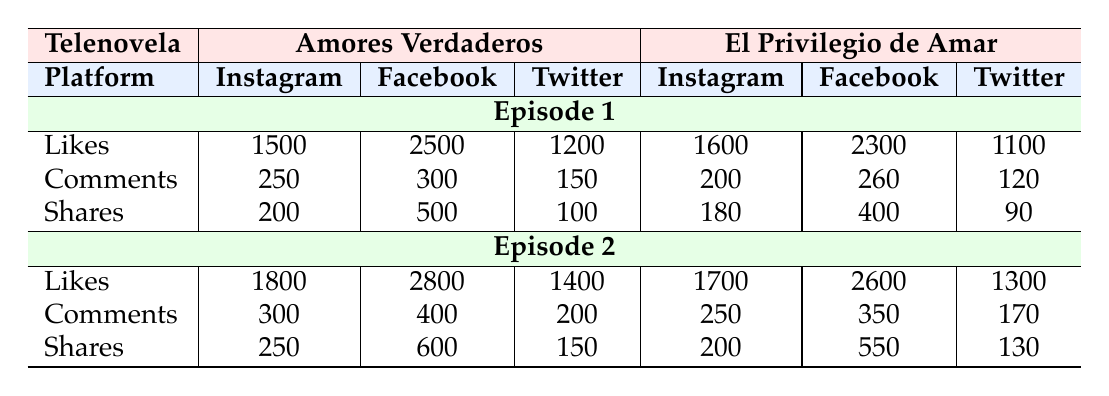What are the total likes for "Amores Verdaderos" Episode 1 across all platforms? To find the total likes for "Amores Verdaderos" Episode 1, we need to sum the likes from Instagram, Facebook, and Twitter: 1500 (Instagram) + 2500 (Facebook) + 1200 (Twitter) = 5200.
Answer: 5200 Which platform had the most shares for "El Privilegio de Amar" Episode 2? For "El Privilegio de Amar" Episode 2, the shares by platform are: Instagram with 200, Facebook with 550, and Twitter with 130. The highest number of shares is from Facebook, which has 550 shares.
Answer: Facebook What is the difference in likes between "Amores Verdaderos" and "El Privilegio de Amar" Episode 1 on Facebook? For Episode 1 on Facebook, "Amores Verdaderos" has 2500 likes, and "El Privilegio de Amar" has 2300 likes. The difference is 2500 - 2300 = 200 likes.
Answer: 200 Did "Amores Verdaderos" Episode 2 have more comments on Instagram than Episode 1? For "Amores Verdaderos" Episode 2 on Instagram, there are 300 comments while Episode 1 has 250 comments. Since 300 is greater than 250, it is true that Episode 2 had more comments.
Answer: Yes What is the average number of shares for "El Privilegio de Amar" across both episodes? For "El Privilegio de Amar," the shares are: Episode 1 has 180 (Instagram), 400 (Facebook), 90 (Twitter) totaling 670 shares. Episode 2 has 200 (Instagram), 550 (Facebook), 130 (Twitter) totaling 880 shares. Therefore, the total shares for both episodes are 670 + 880 = 1550. There are 2 episodes, so the average is 1550/2 = 775 shares.
Answer: 775 Which episode of "El Privilegio de Amar" received the highest engagement (likes + comments + shares) on Facebook? For Episode 1 on Facebook: Likes (2300) + Comments (260) + Shares (400) = 2960. For Episode 2 on Facebook: Likes (2600) + Comments (350) + Shares (550) = 3500. Comparing these, Episode 2 has more engagement with 3500.
Answer: Episode 2 How many total comments were there for "Amores Verdaderos" on Twitter across both episodes? The total comments on Twitter for "Amores Verdaderos" Episode 1 is 150, and for Episode 2, it's 200. Summing these gives us 150 + 200 = 350 comments.
Answer: 350 Was there a decrease in the number of likes from Episode 1 to Episode 2 for "El Privilegio de Amar" on Twitter? For "El Privilegio de Amar" Episode 1 on Twitter, the likes are 1100, and for Episode 2, they are 1300. Since 1300 is greater than 1100, there was no decrease in likes.
Answer: No 